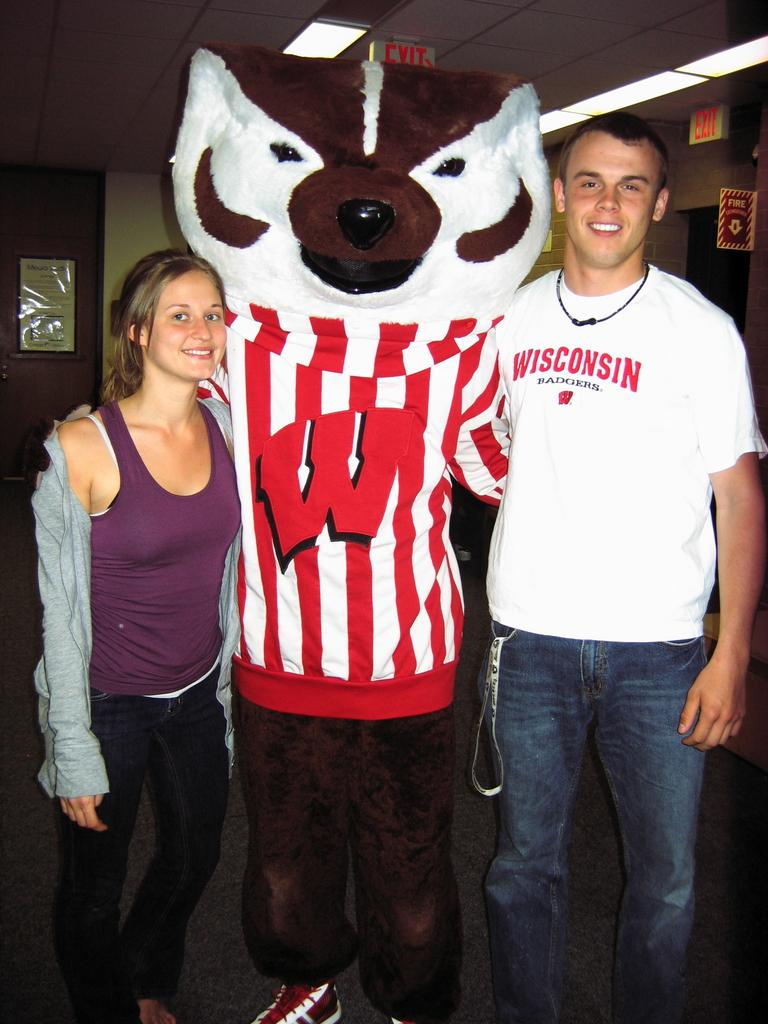<image>
Describe the image concisely. two people taking a photo with a mascot wearing a shirt that says 'w' on it 